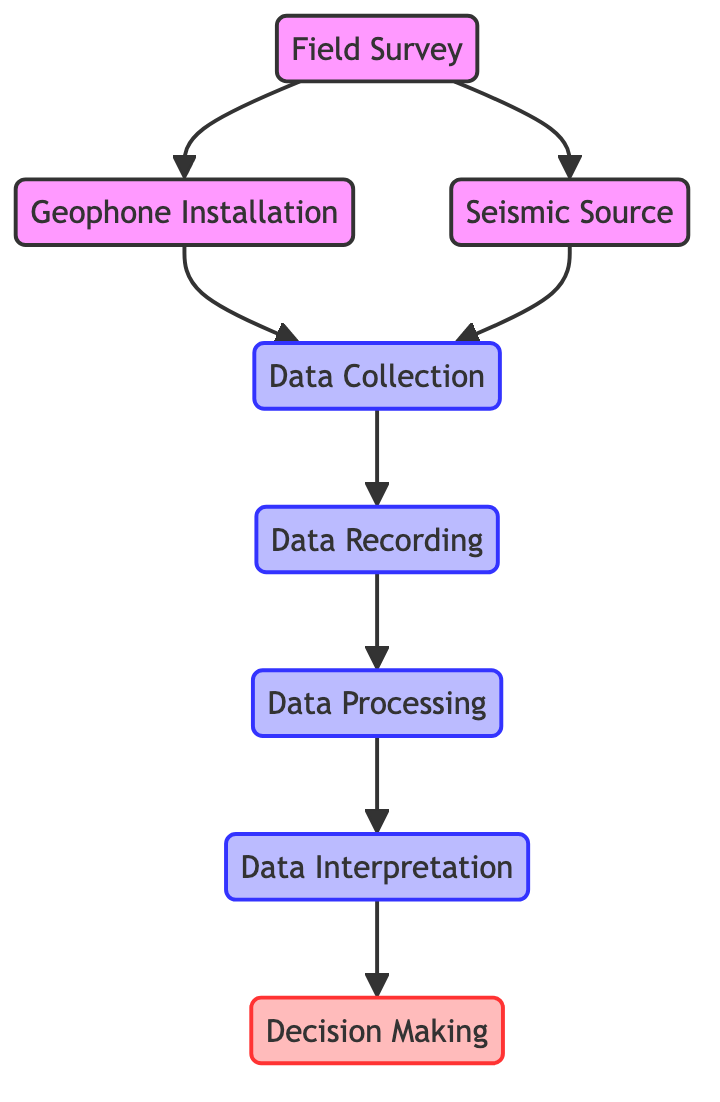What is the last step in the seismic data acquisition workflow? The last step in the workflow is "Decision Making," which is represented as the final node connected to the "Data Interpretation" node.
Answer: Decision Making How many total nodes are there in the diagram? There are eight nodes in the diagram, which represent different steps in the seismic data acquisition workflow.
Answer: Eight What does "Data Processing" lead to? "Data Processing" leads to "Data Interpretation," as shown by the directed edge pointing from "Data Processing" to "Data Interpretation."
Answer: Data Interpretation Which node is connected to both "Geophone Installation" and "Seismic Source"? The node "Data Collection" is the one that is connected to both "Geophone Installation" and "Seismic Source," indicating it collects data from both.
Answer: Data Collection What is the relationship between "Field Survey" and "Geophone Installation"? The relationship is that "Field Survey" points to "Geophone Installation," indicating that conducting a field survey is necessary before the installation of geophones can take place.
Answer: Pointing What are the two types of activities that lead to "Data Collection"? The two types of activities that lead to "Data Collection" are "Geophone Installation" and "Seismic Source," both contributing to the gathering of seismic data.
Answer: Geophone Installation and Seismic Source Which step directly precedes "Data Interpretation"? The step that directly precedes "Data Interpretation" is "Data Processing," as evident from the direct edge connecting these two nodes.
Answer: Data Processing What initiates the entire workflow depicted in the diagram? The workflow is initiated by the "Field Survey," which is the first step that identifies suitable locations for seismic data acquisition.
Answer: Field Survey 